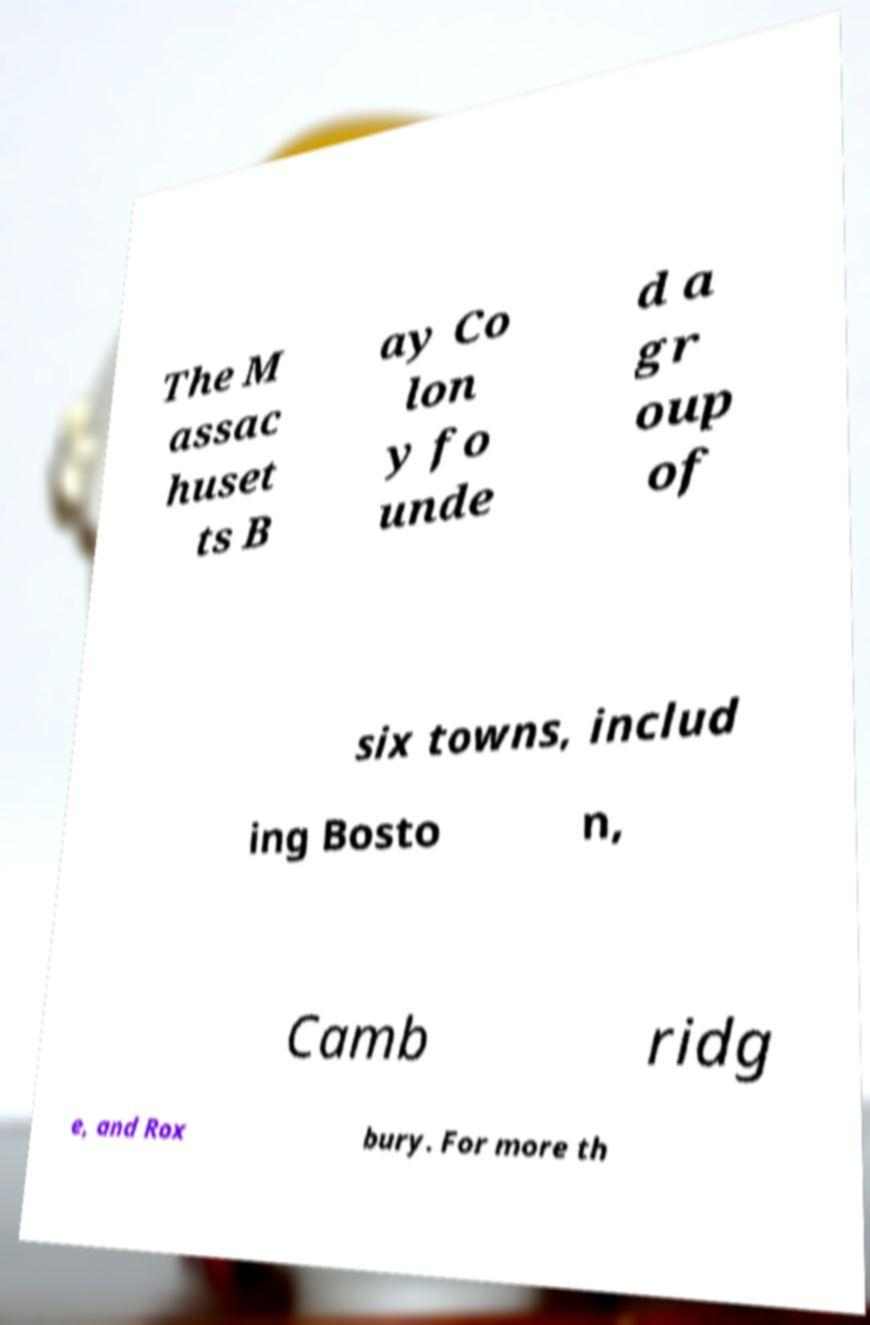Could you extract and type out the text from this image? The M assac huset ts B ay Co lon y fo unde d a gr oup of six towns, includ ing Bosto n, Camb ridg e, and Rox bury. For more th 